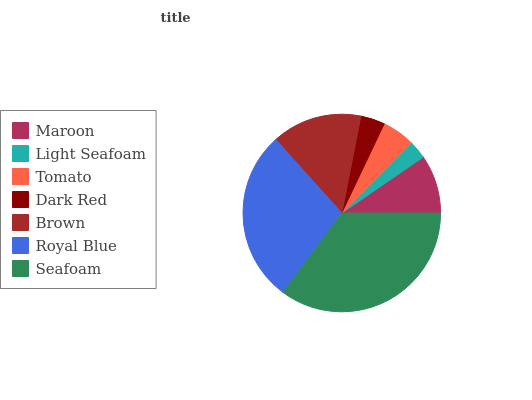Is Light Seafoam the minimum?
Answer yes or no. Yes. Is Seafoam the maximum?
Answer yes or no. Yes. Is Tomato the minimum?
Answer yes or no. No. Is Tomato the maximum?
Answer yes or no. No. Is Tomato greater than Light Seafoam?
Answer yes or no. Yes. Is Light Seafoam less than Tomato?
Answer yes or no. Yes. Is Light Seafoam greater than Tomato?
Answer yes or no. No. Is Tomato less than Light Seafoam?
Answer yes or no. No. Is Maroon the high median?
Answer yes or no. Yes. Is Maroon the low median?
Answer yes or no. Yes. Is Dark Red the high median?
Answer yes or no. No. Is Brown the low median?
Answer yes or no. No. 